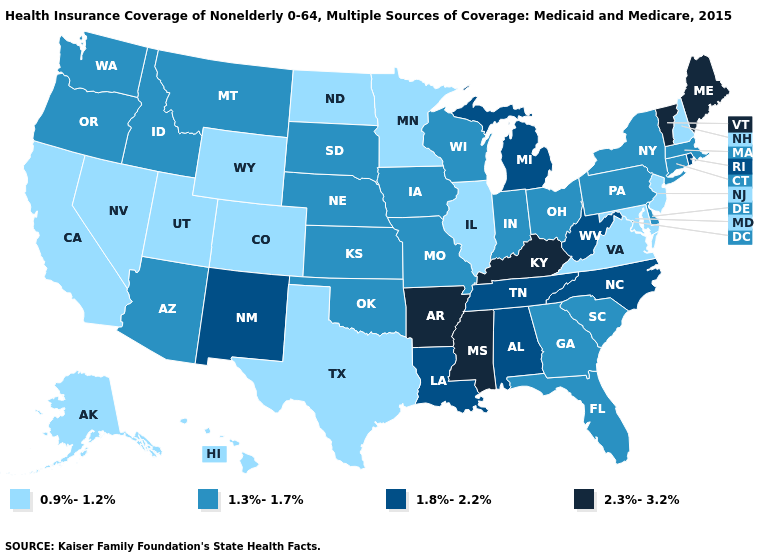Does Rhode Island have a lower value than Michigan?
Short answer required. No. Does Mississippi have a lower value than Montana?
Be succinct. No. Name the states that have a value in the range 1.3%-1.7%?
Quick response, please. Arizona, Connecticut, Delaware, Florida, Georgia, Idaho, Indiana, Iowa, Kansas, Massachusetts, Missouri, Montana, Nebraska, New York, Ohio, Oklahoma, Oregon, Pennsylvania, South Carolina, South Dakota, Washington, Wisconsin. Name the states that have a value in the range 2.3%-3.2%?
Answer briefly. Arkansas, Kentucky, Maine, Mississippi, Vermont. What is the lowest value in states that border Maine?
Keep it brief. 0.9%-1.2%. Does Minnesota have the lowest value in the USA?
Be succinct. Yes. Among the states that border Arizona , does New Mexico have the lowest value?
Quick response, please. No. What is the value of Alabama?
Be succinct. 1.8%-2.2%. What is the value of Connecticut?
Quick response, please. 1.3%-1.7%. Name the states that have a value in the range 0.9%-1.2%?
Short answer required. Alaska, California, Colorado, Hawaii, Illinois, Maryland, Minnesota, Nevada, New Hampshire, New Jersey, North Dakota, Texas, Utah, Virginia, Wyoming. Is the legend a continuous bar?
Write a very short answer. No. What is the value of Connecticut?
Keep it brief. 1.3%-1.7%. Does Virginia have the lowest value in the South?
Give a very brief answer. Yes. Does California have the same value as Delaware?
Quick response, please. No. 